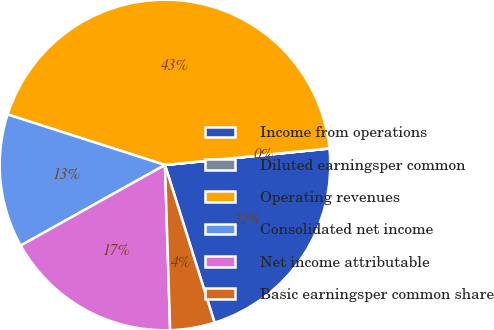Convert chart to OTSL. <chart><loc_0><loc_0><loc_500><loc_500><pie_chart><fcel>Income from operations<fcel>Diluted earningsper common<fcel>Operating revenues<fcel>Consolidated net income<fcel>Net income attributable<fcel>Basic earningsper common share<nl><fcel>21.74%<fcel>0.01%<fcel>43.46%<fcel>13.05%<fcel>17.39%<fcel>4.35%<nl></chart> 